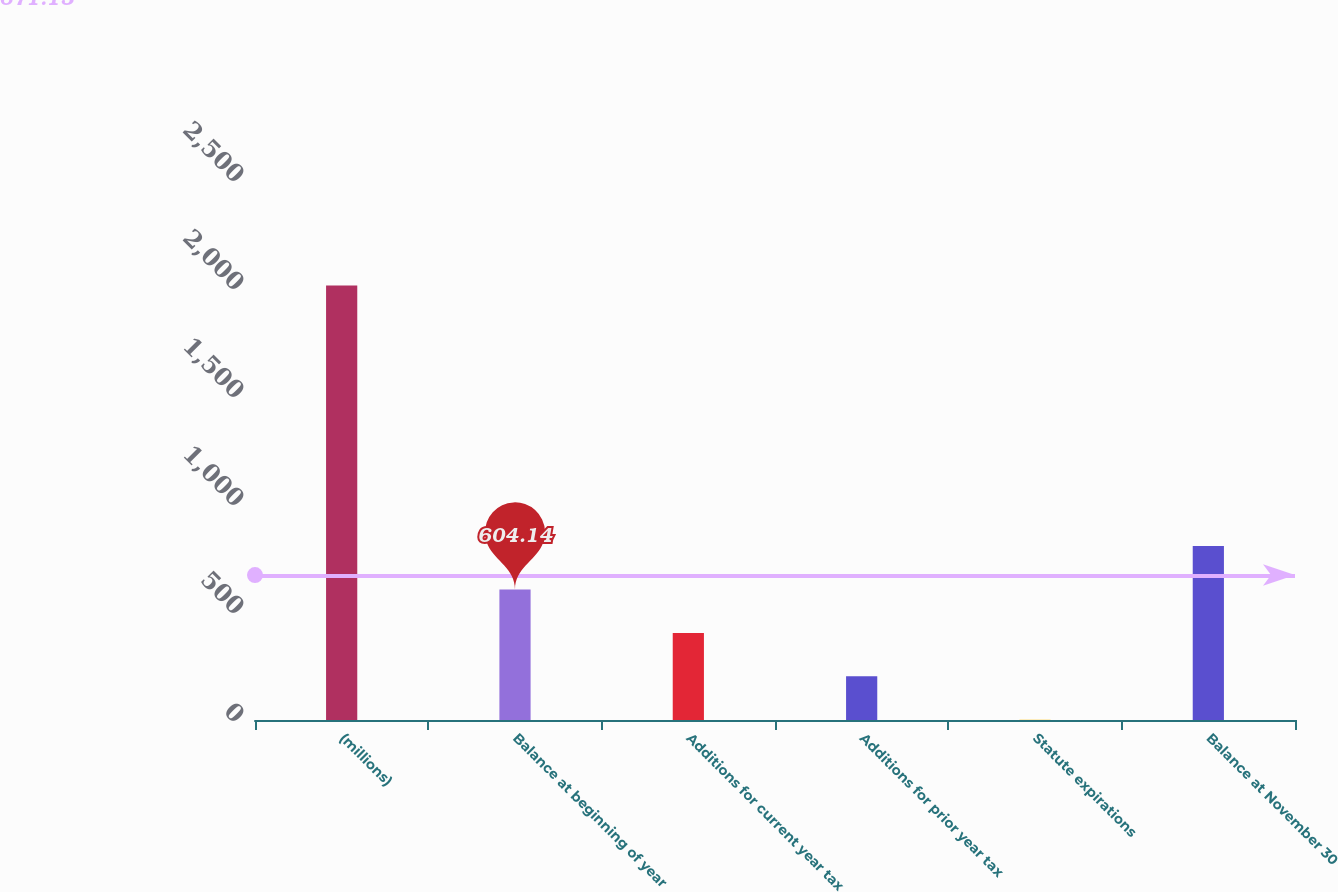Convert chart. <chart><loc_0><loc_0><loc_500><loc_500><bar_chart><fcel>(millions)<fcel>Balance at beginning of year<fcel>Additions for current year tax<fcel>Additions for prior year tax<fcel>Statute expirations<fcel>Balance at November 30<nl><fcel>2011<fcel>604.14<fcel>403.16<fcel>202.18<fcel>1.2<fcel>805.12<nl></chart> 